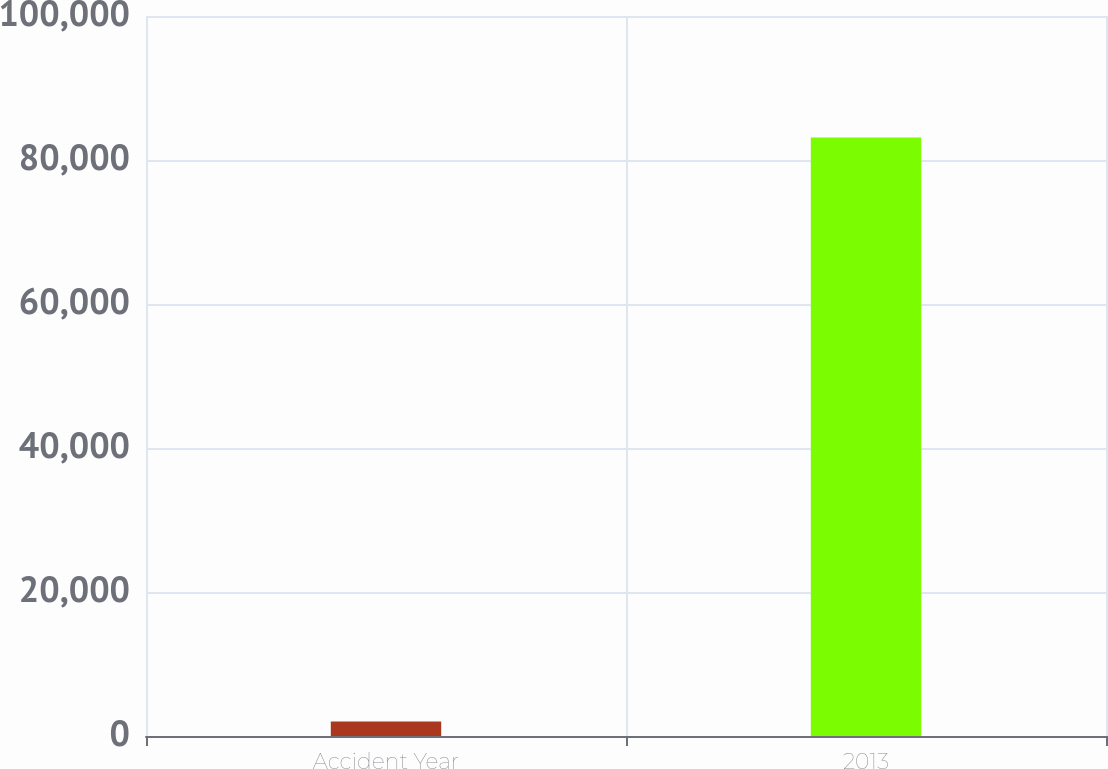<chart> <loc_0><loc_0><loc_500><loc_500><bar_chart><fcel>Accident Year<fcel>2013<nl><fcel>2016<fcel>83119<nl></chart> 